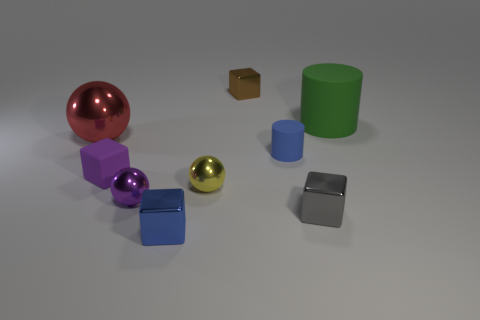Subtract 2 cubes. How many cubes are left? 2 Add 1 tiny rubber spheres. How many objects exist? 10 Subtract all blocks. How many objects are left? 5 Subtract all gray balls. Subtract all tiny gray shiny things. How many objects are left? 8 Add 6 tiny brown metal cubes. How many tiny brown metal cubes are left? 7 Add 2 tiny shiny blocks. How many tiny shiny blocks exist? 5 Subtract 1 purple spheres. How many objects are left? 8 